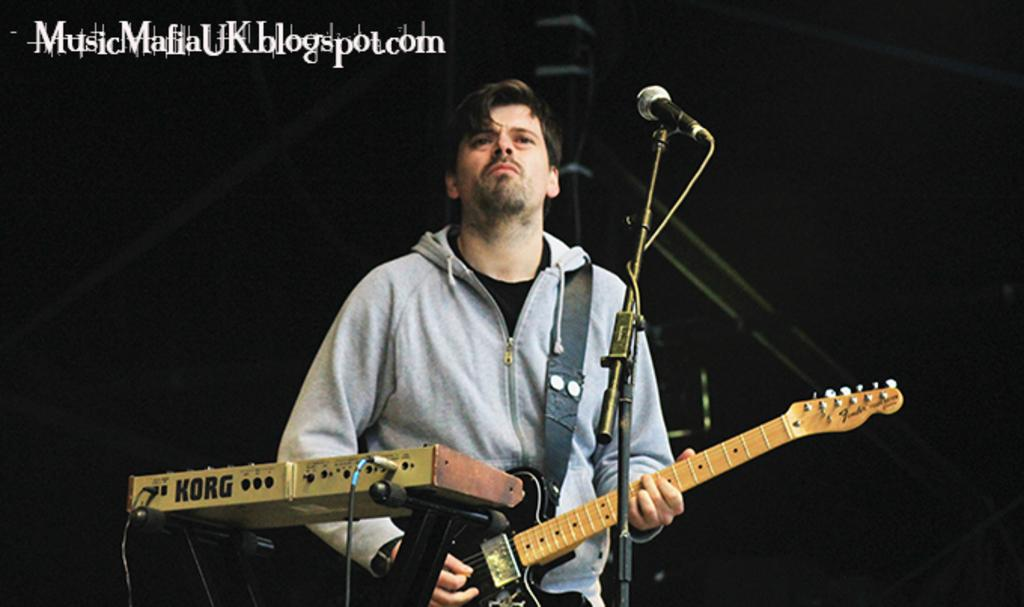What is the man doing on the stage in the image? The man is playing a guitar on the stage. What is the man standing in front of? The man is in front of a microphone stand. What other musical equipment is visible in the image? There is a music player beside the man. How many books can be seen on the stage in the image? There are no books visible in the image; it features a man playing a guitar on the stage. What type of fruit is the man holding while playing the guitar? There is no fruit present in the image; the man is playing a guitar and standing in front of a microphone stand. 